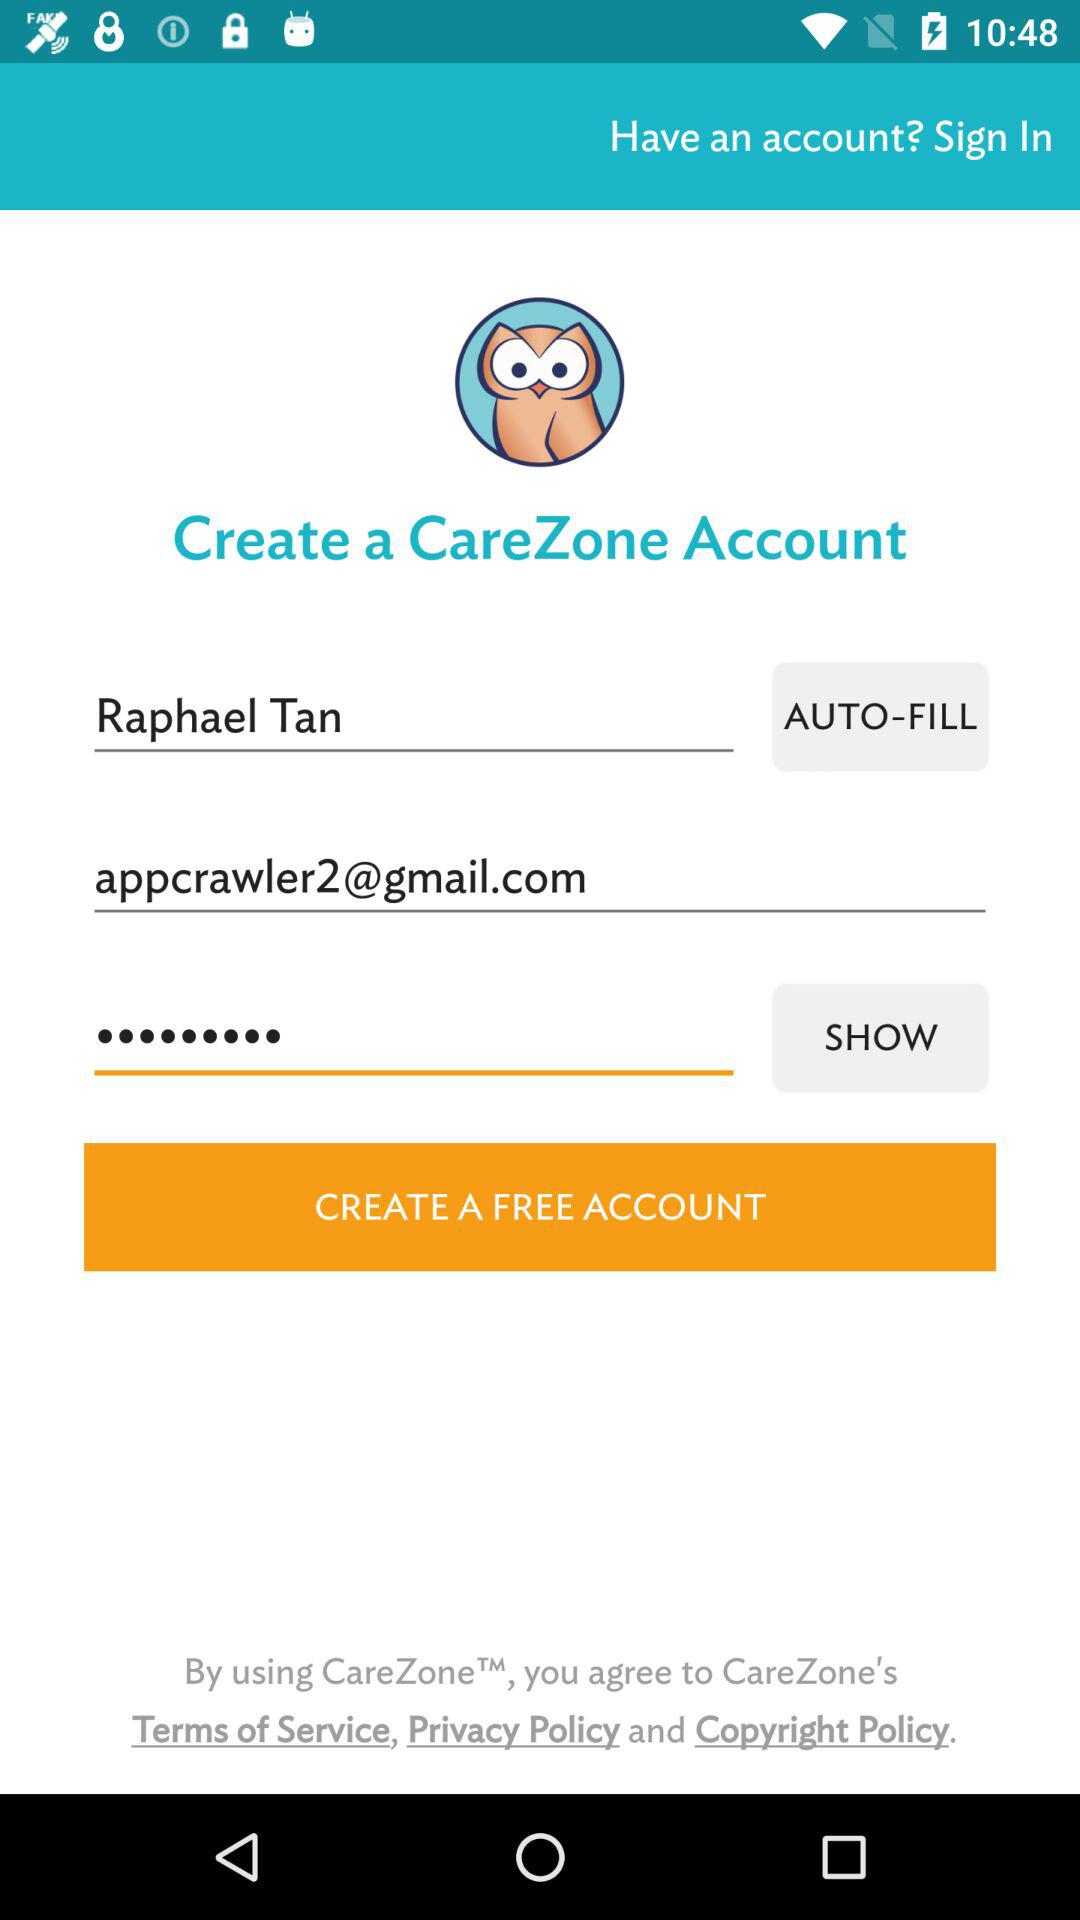What is the email address? The email address is appcrawler2@gmail.com. 